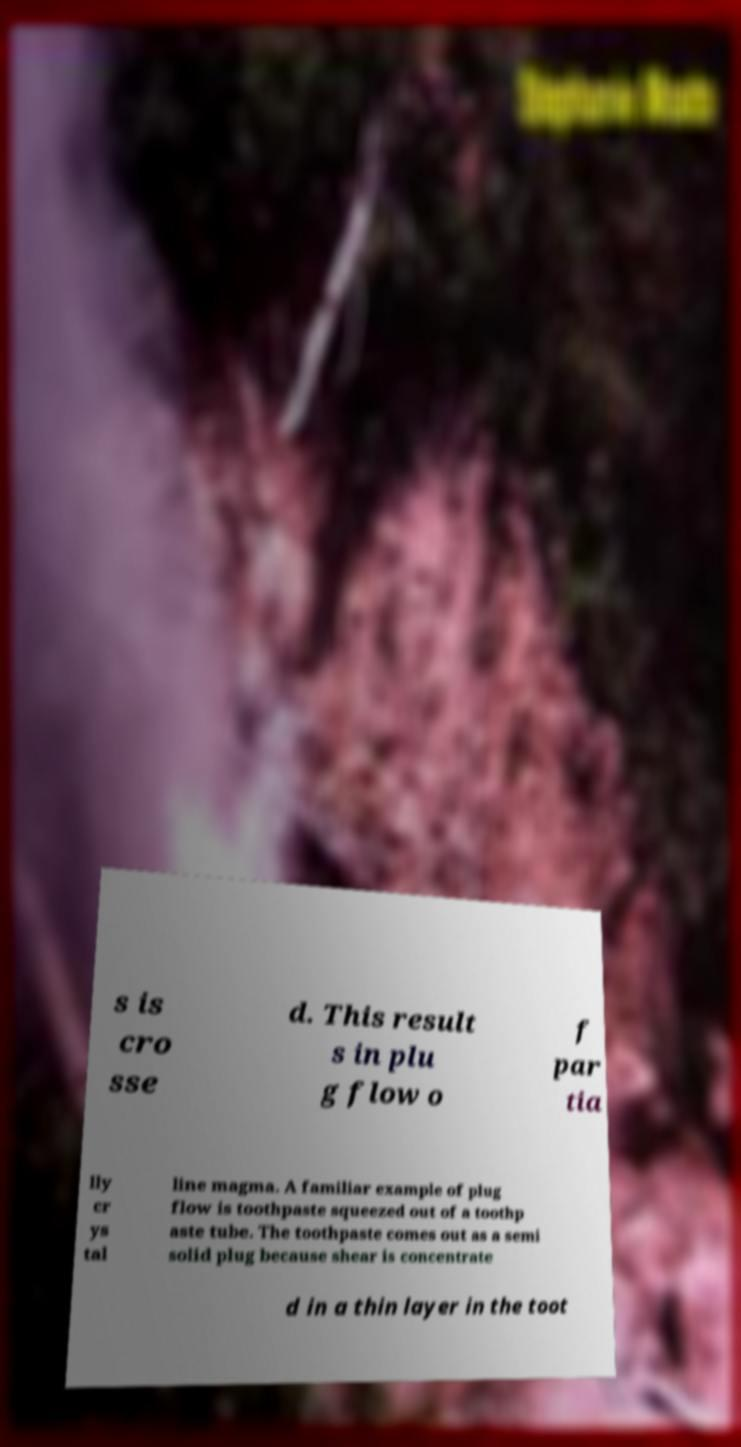Could you extract and type out the text from this image? s is cro sse d. This result s in plu g flow o f par tia lly cr ys tal line magma. A familiar example of plug flow is toothpaste squeezed out of a toothp aste tube. The toothpaste comes out as a semi solid plug because shear is concentrate d in a thin layer in the toot 